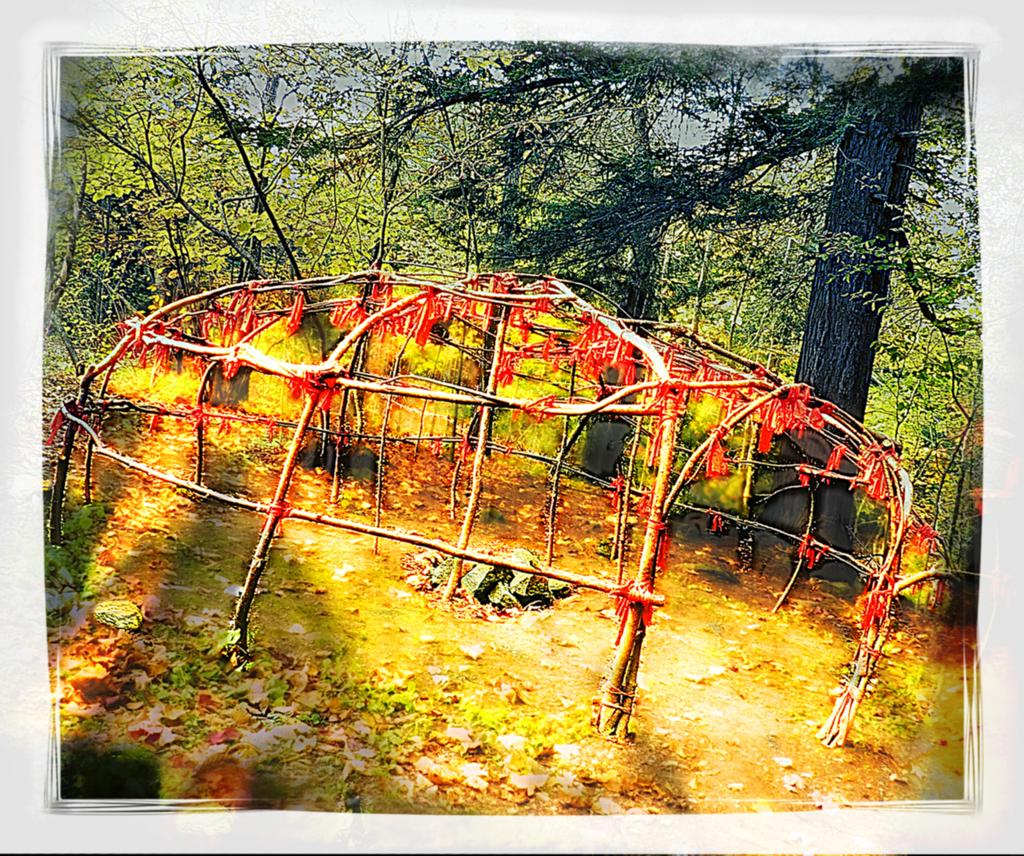What is located in the center of the image? There is a fence in the center of the image. What can be seen in the background of the image? There are trees in the background of the image. What is present at the bottom of the image? There are leaves at the bottom of the image. What type of glass is being used for the competition in the image? There is no competition or glass present in the image. 